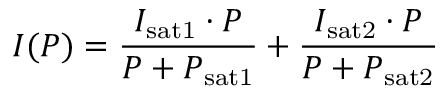Convert formula to latex. <formula><loc_0><loc_0><loc_500><loc_500>I ( P ) = \frac { I _ { s a t 1 } \cdot P } { P + P _ { s a t 1 } } + \frac { I _ { s a t 2 } \cdot P } { P + P _ { s a t 2 } }</formula> 